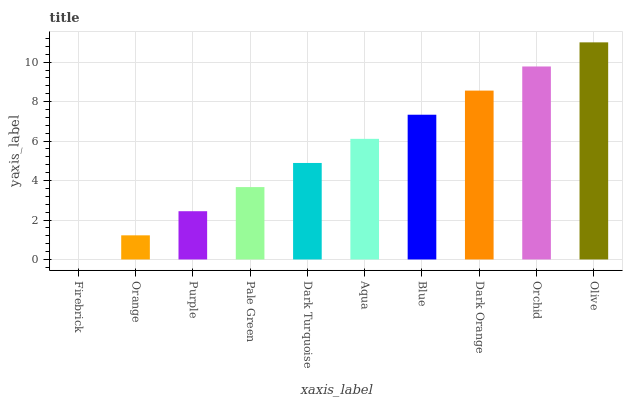Is Orange the minimum?
Answer yes or no. No. Is Orange the maximum?
Answer yes or no. No. Is Orange greater than Firebrick?
Answer yes or no. Yes. Is Firebrick less than Orange?
Answer yes or no. Yes. Is Firebrick greater than Orange?
Answer yes or no. No. Is Orange less than Firebrick?
Answer yes or no. No. Is Aqua the high median?
Answer yes or no. Yes. Is Dark Turquoise the low median?
Answer yes or no. Yes. Is Dark Orange the high median?
Answer yes or no. No. Is Orange the low median?
Answer yes or no. No. 